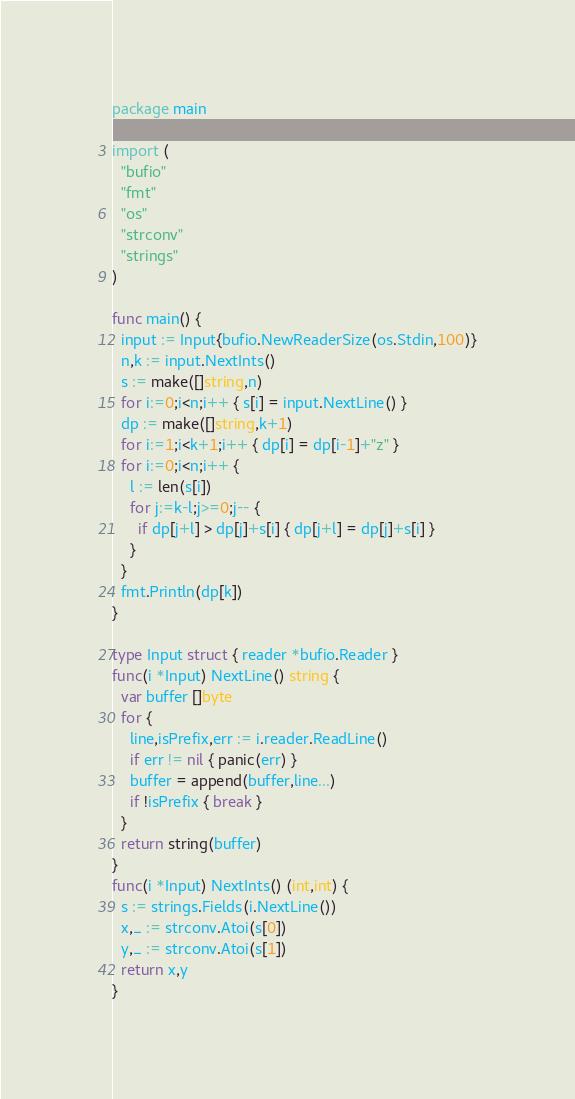Convert code to text. <code><loc_0><loc_0><loc_500><loc_500><_Go_>package main

import (
  "bufio"
  "fmt"
  "os"
  "strconv"
  "strings"
)

func main() {
  input := Input{bufio.NewReaderSize(os.Stdin,100)}
  n,k := input.NextInts()
  s := make([]string,n)
  for i:=0;i<n;i++ { s[i] = input.NextLine() }
  dp := make([]string,k+1)
  for i:=1;i<k+1;i++ { dp[i] = dp[i-1]+"z" }
  for i:=0;i<n;i++ {
    l := len(s[i])
    for j:=k-l;j>=0;j-- {
      if dp[j+l] > dp[j]+s[i] { dp[j+l] = dp[j]+s[i] }
    }
  }
  fmt.Println(dp[k])
}

type Input struct { reader *bufio.Reader }
func(i *Input) NextLine() string {
  var buffer []byte
  for {
    line,isPrefix,err := i.reader.ReadLine()
    if err != nil { panic(err) }
    buffer = append(buffer,line...)
    if !isPrefix { break }
  }
  return string(buffer)
}
func(i *Input) NextInts() (int,int) {
  s := strings.Fields(i.NextLine())
  x,_ := strconv.Atoi(s[0])
  y,_ := strconv.Atoi(s[1])
  return x,y
}</code> 